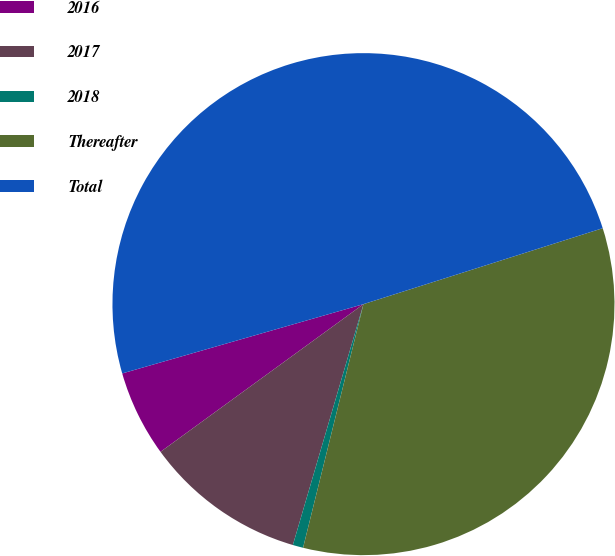Convert chart to OTSL. <chart><loc_0><loc_0><loc_500><loc_500><pie_chart><fcel>2016<fcel>2017<fcel>2018<fcel>Thereafter<fcel>Total<nl><fcel>5.56%<fcel>10.45%<fcel>0.67%<fcel>33.76%<fcel>49.56%<nl></chart> 